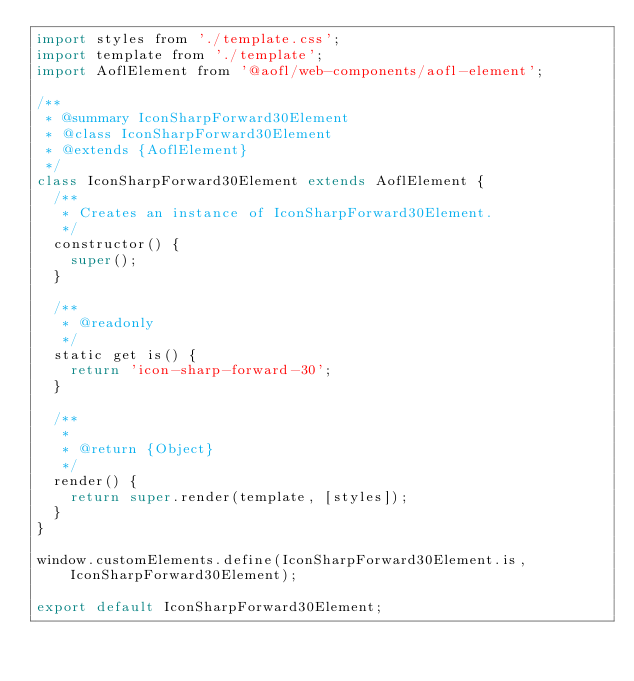Convert code to text. <code><loc_0><loc_0><loc_500><loc_500><_JavaScript_>import styles from './template.css';
import template from './template';
import AoflElement from '@aofl/web-components/aofl-element';

/**
 * @summary IconSharpForward30Element
 * @class IconSharpForward30Element
 * @extends {AoflElement}
 */
class IconSharpForward30Element extends AoflElement {
  /**
   * Creates an instance of IconSharpForward30Element.
   */
  constructor() {
    super();
  }

  /**
   * @readonly
   */
  static get is() {
    return 'icon-sharp-forward-30';
  }

  /**
   *
   * @return {Object}
   */
  render() {
    return super.render(template, [styles]);
  }
}

window.customElements.define(IconSharpForward30Element.is, IconSharpForward30Element);

export default IconSharpForward30Element;
</code> 